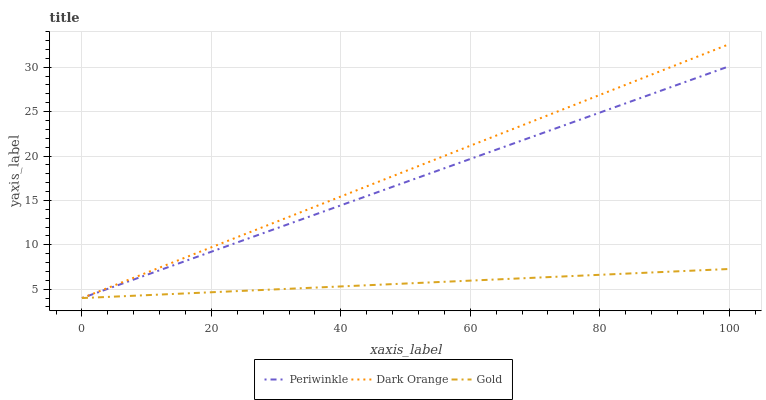Does Gold have the minimum area under the curve?
Answer yes or no. Yes. Does Dark Orange have the maximum area under the curve?
Answer yes or no. Yes. Does Periwinkle have the minimum area under the curve?
Answer yes or no. No. Does Periwinkle have the maximum area under the curve?
Answer yes or no. No. Is Gold the smoothest?
Answer yes or no. Yes. Is Periwinkle the roughest?
Answer yes or no. Yes. Is Periwinkle the smoothest?
Answer yes or no. No. Is Gold the roughest?
Answer yes or no. No. Does Dark Orange have the lowest value?
Answer yes or no. Yes. Does Dark Orange have the highest value?
Answer yes or no. Yes. Does Periwinkle have the highest value?
Answer yes or no. No. Does Gold intersect Dark Orange?
Answer yes or no. Yes. Is Gold less than Dark Orange?
Answer yes or no. No. Is Gold greater than Dark Orange?
Answer yes or no. No. 